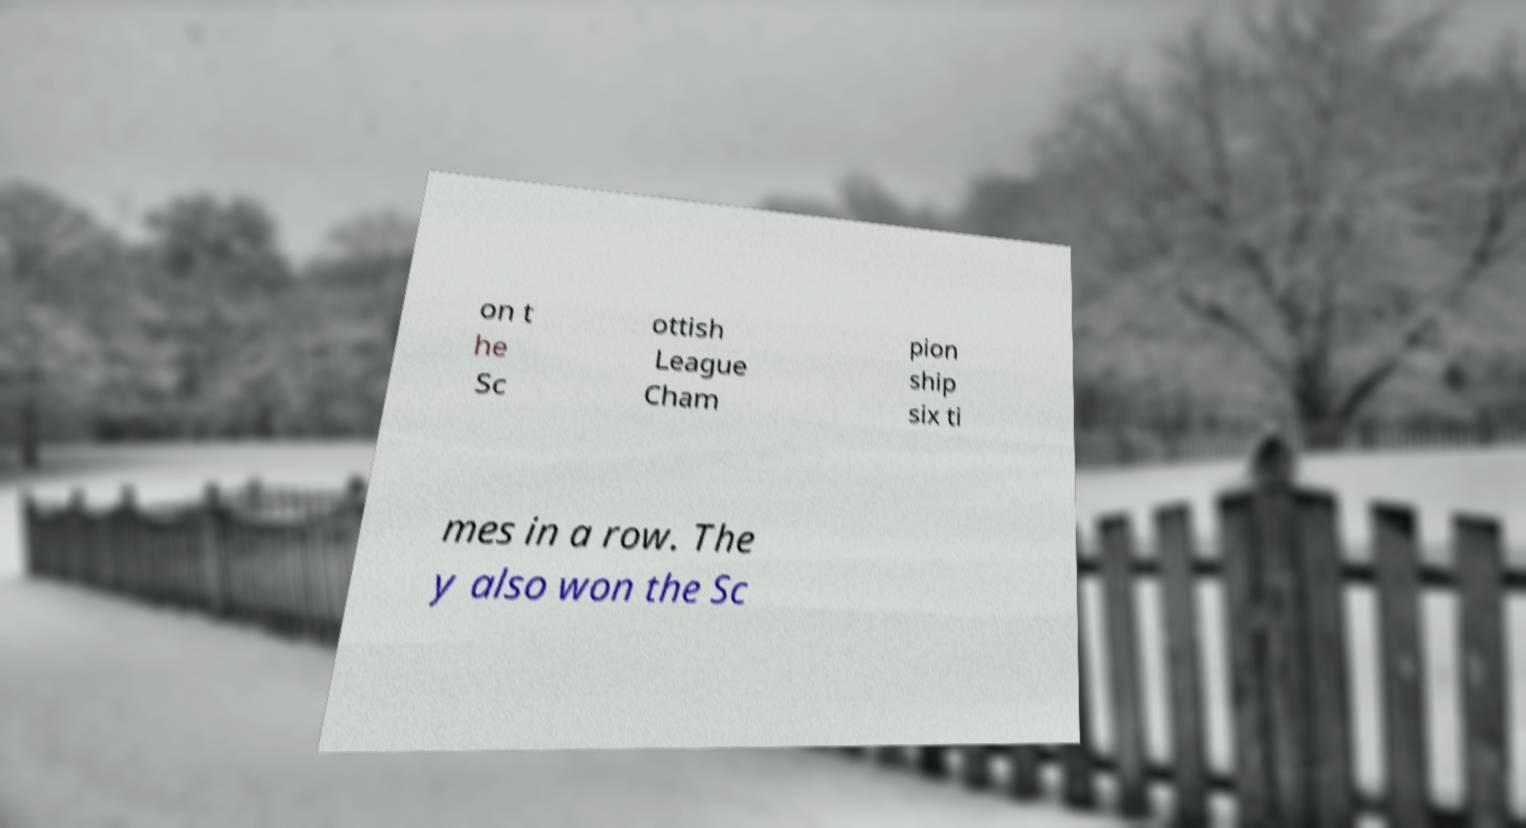I need the written content from this picture converted into text. Can you do that? on t he Sc ottish League Cham pion ship six ti mes in a row. The y also won the Sc 